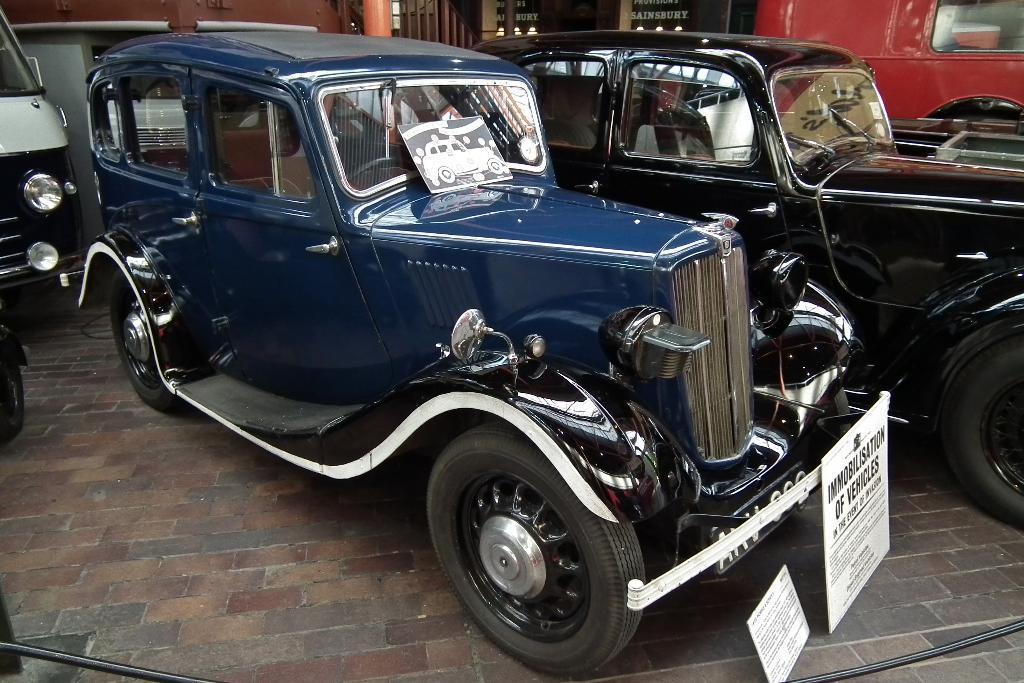In one or two sentences, can you explain what this image depicts? In this image we can see cars on the ground, there is the windshield, there is the steering, there's the door, there are the tires, there is the name plate on it. 